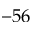<formula> <loc_0><loc_0><loc_500><loc_500>- 5 6</formula> 